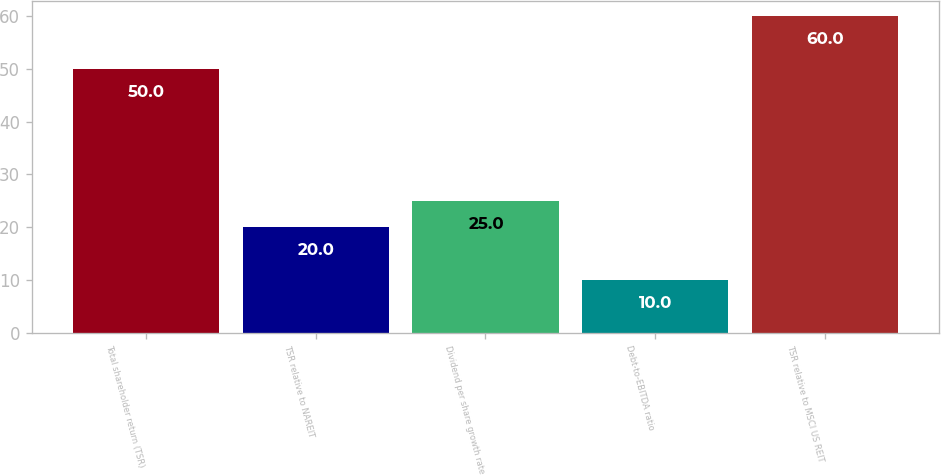Convert chart to OTSL. <chart><loc_0><loc_0><loc_500><loc_500><bar_chart><fcel>Total shareholder return (TSR)<fcel>TSR relative to NAREIT<fcel>Dividend per share growth rate<fcel>Debt-to-EBITDA ratio<fcel>TSR relative to MSCI US REIT<nl><fcel>50<fcel>20<fcel>25<fcel>10<fcel>60<nl></chart> 